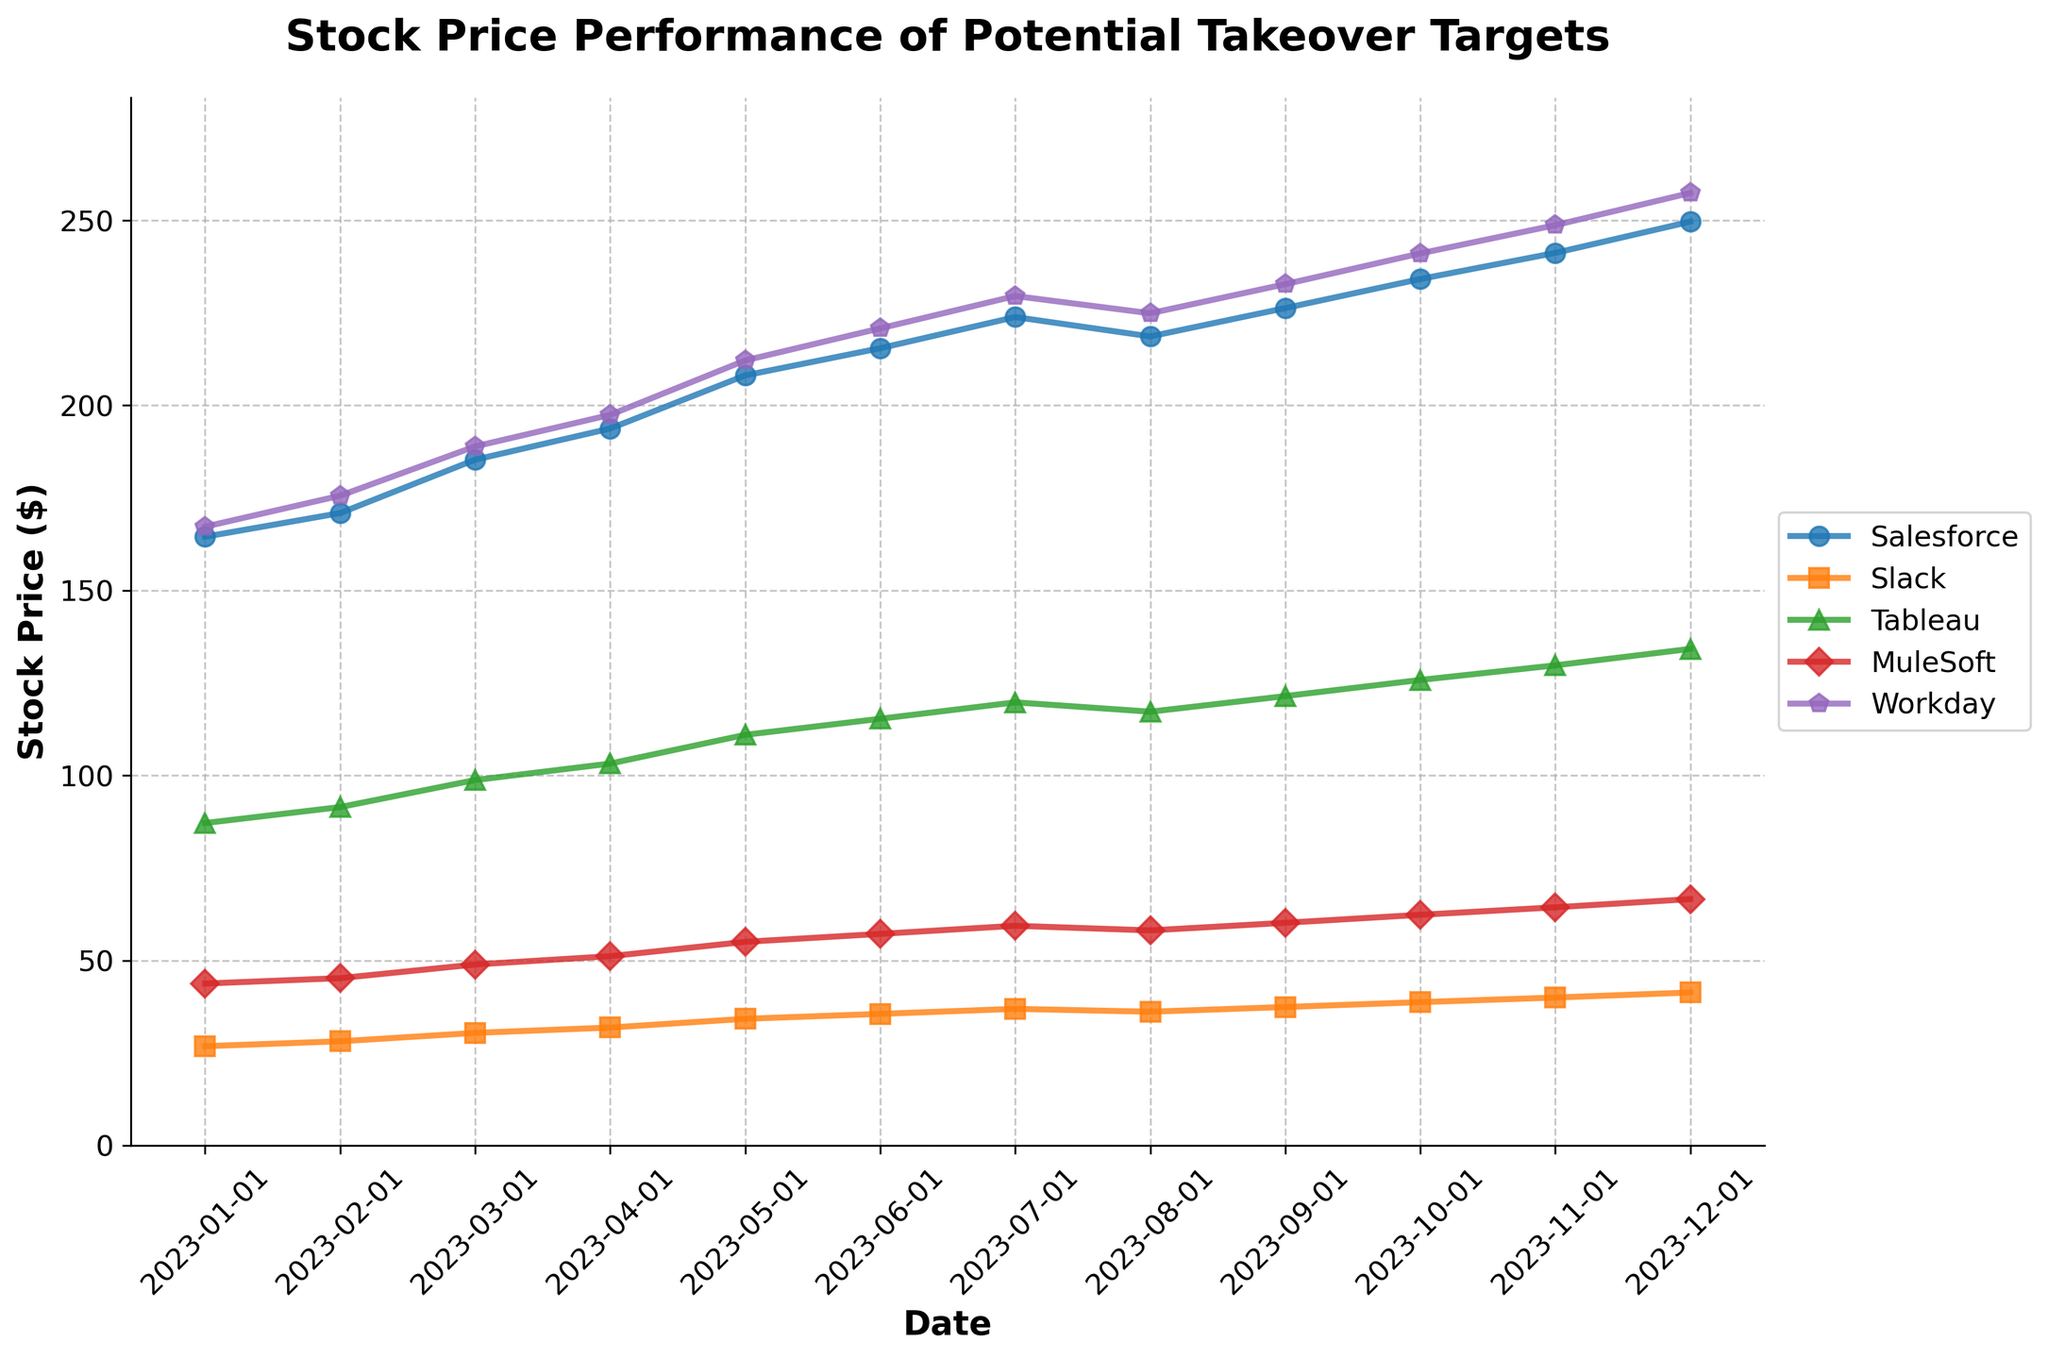which company experienced the highest stock price increase from january to december 2023? To find which company experienced the highest stock price increase, calculate the difference between the December and January stock prices for each company. Salesforce: 249.67 - 164.52 = 85.15, Slack: 41.34 - 26.83 = 14.51, Tableau: 134.21 - 87.14 = 47.07, MuleSoft: 66.58 - 43.76 = 22.82, Workday: 257.43 - 167.24 = 90.19. Workday has the highest increase.
Answer: Workday which month did tableau's stock price surpass 100 for the first time in 2023? Look at Tableau's stock price progression in the chart: Tableau surpassed 100 for the first time in April 2023, with a price of 103.21.
Answer: April 2023 by how much did muleSoft's stock price	change between may and november? Find MuleSoft's stock price in May and November and subtract the May value from the November value. MuleSoft's stock price in May is 55.03, and in November is 64.37. Calculation: 64.37 - 55.03 = 9.34.
Answer: 9.34 which company had the smallest fluctuation in its stock price in 2023? To find the smallest fluctuation, calculate the range (highest - lowest) of the stock prices for each company throughout the year. Smallest difference indicates smallest fluctuation. Salesforce: 85.15, Slack: 14.51, Tableau: 47.07, MuleSoft: 22.82, Workday: 90.19. Slack has the smallest fluctuation.
Answer: Slack in how many months did salesforce's stock price increase continuously? Look at Salesforce's stock price month by month for continuous increase periods. There was a continuous increase from January to July (2023-01-01 to 2023-07-01). Salesforce's continuously increased for 7 months.
Answer: 7 months which company saw a decline in its stock price in august 2023, compared to july 2023? Find the companies whose stock price in August 2023 is less than in July 2023. Salesforce went from 223.89 to 218.65. Salesforce saw a decline in August 2023.
Answer: Salesforce what is the average stock price of slack over the first half of 2023? Calculate the average of Slack's stock price from January to June. (26.83 + 28.15 + 30.42 + 31.87 + 34.23 + 35.56) / 6 = 31.51
Answer: 31.51 which company had the highest stock price in december 2023? Compare the stock prices of each company in December 2023. Salesforce: 249.67, Slack: 41.34, Tableau: 134.21, MuleSoft: 66.58, Workday: 257.43. Workday had the highest stock price in December 2023.
Answer: Workday by how much did workday's stock price change from august to september 2023? Find Workday's stock price in August and September and subtract the August value from the September value. Workday's stock price in August is 224.91, and in September is 232.78. Calculation: 232.78 - 224.91 = 7.87.
Answer: 7.87 